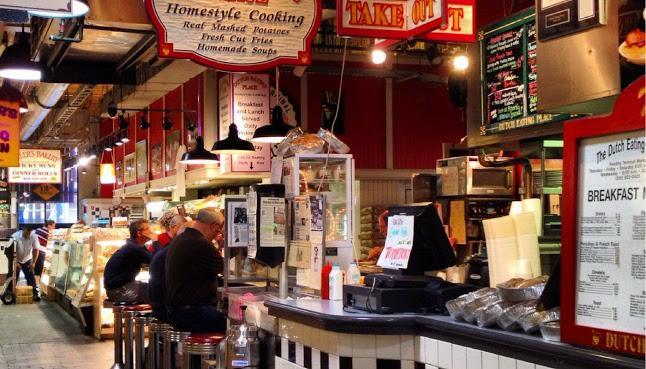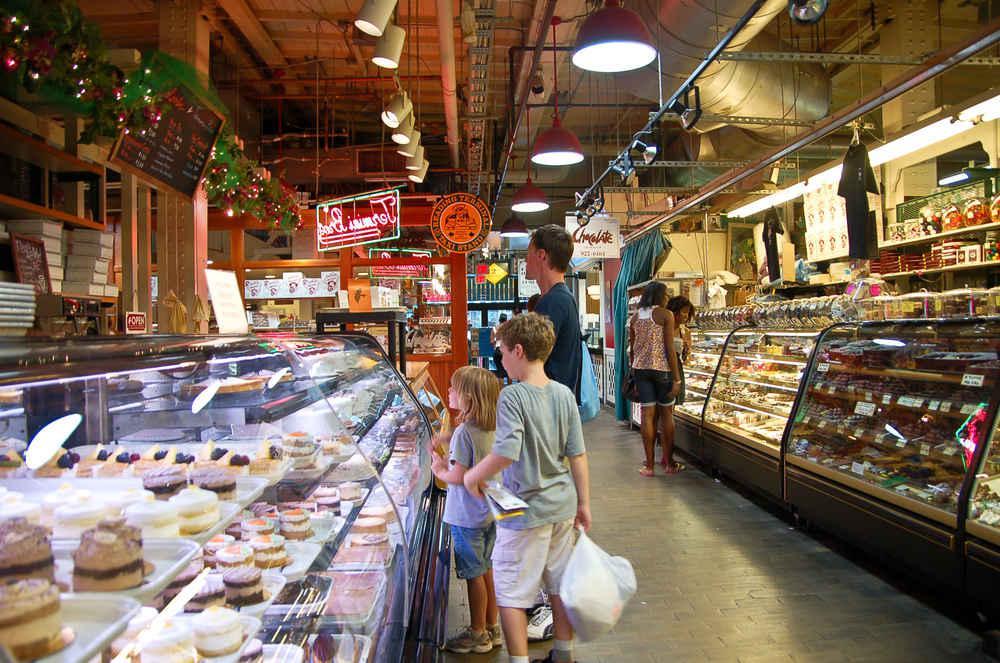The first image is the image on the left, the second image is the image on the right. Assess this claim about the two images: "More than six people are sitting on bar stools.". Correct or not? Answer yes or no. No. 